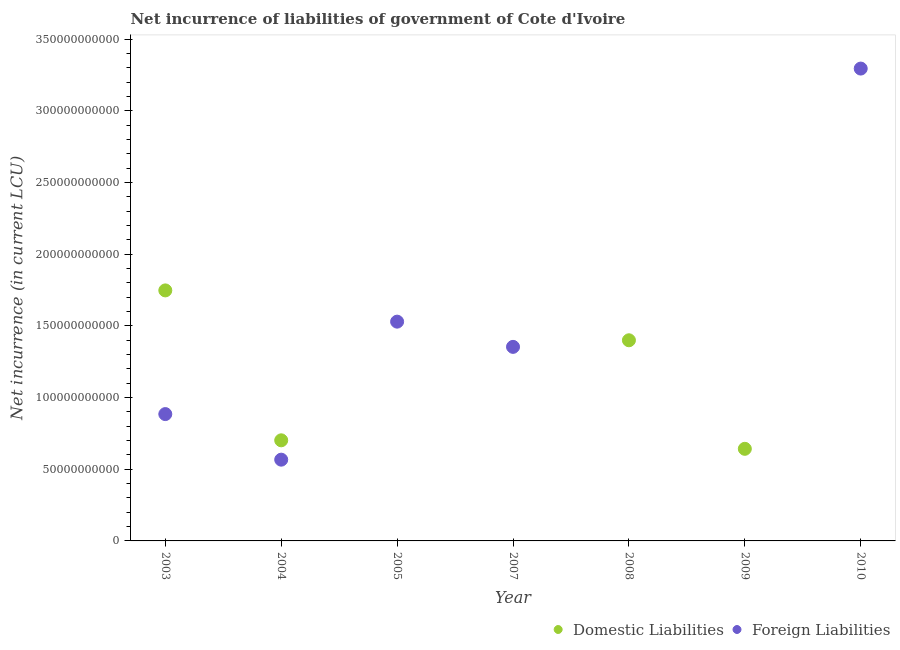What is the net incurrence of foreign liabilities in 2004?
Give a very brief answer. 5.67e+1. Across all years, what is the maximum net incurrence of foreign liabilities?
Ensure brevity in your answer.  3.30e+11. Across all years, what is the minimum net incurrence of foreign liabilities?
Provide a short and direct response. 0. In which year was the net incurrence of domestic liabilities maximum?
Ensure brevity in your answer.  2003. What is the total net incurrence of domestic liabilities in the graph?
Ensure brevity in your answer.  4.49e+11. What is the difference between the net incurrence of foreign liabilities in 2003 and that in 2007?
Offer a terse response. -4.69e+1. What is the difference between the net incurrence of foreign liabilities in 2004 and the net incurrence of domestic liabilities in 2005?
Your answer should be very brief. 5.67e+1. What is the average net incurrence of foreign liabilities per year?
Your answer should be very brief. 1.09e+11. In the year 2003, what is the difference between the net incurrence of foreign liabilities and net incurrence of domestic liabilities?
Offer a very short reply. -8.63e+1. In how many years, is the net incurrence of domestic liabilities greater than 90000000000 LCU?
Ensure brevity in your answer.  2. What is the ratio of the net incurrence of foreign liabilities in 2007 to that in 2010?
Ensure brevity in your answer.  0.41. Is the net incurrence of foreign liabilities in 2005 less than that in 2007?
Ensure brevity in your answer.  No. What is the difference between the highest and the second highest net incurrence of foreign liabilities?
Provide a short and direct response. 1.77e+11. What is the difference between the highest and the lowest net incurrence of foreign liabilities?
Ensure brevity in your answer.  3.30e+11. In how many years, is the net incurrence of domestic liabilities greater than the average net incurrence of domestic liabilities taken over all years?
Keep it short and to the point. 4. Is the net incurrence of domestic liabilities strictly less than the net incurrence of foreign liabilities over the years?
Your response must be concise. No. How many years are there in the graph?
Ensure brevity in your answer.  7. What is the difference between two consecutive major ticks on the Y-axis?
Offer a terse response. 5.00e+1. Are the values on the major ticks of Y-axis written in scientific E-notation?
Offer a terse response. No. Does the graph contain any zero values?
Your response must be concise. Yes. Does the graph contain grids?
Your response must be concise. No. How are the legend labels stacked?
Offer a very short reply. Horizontal. What is the title of the graph?
Offer a very short reply. Net incurrence of liabilities of government of Cote d'Ivoire. What is the label or title of the Y-axis?
Your response must be concise. Net incurrence (in current LCU). What is the Net incurrence (in current LCU) of Domestic Liabilities in 2003?
Provide a short and direct response. 1.75e+11. What is the Net incurrence (in current LCU) of Foreign Liabilities in 2003?
Your answer should be very brief. 8.85e+1. What is the Net incurrence (in current LCU) of Domestic Liabilities in 2004?
Offer a terse response. 7.02e+1. What is the Net incurrence (in current LCU) of Foreign Liabilities in 2004?
Offer a very short reply. 5.67e+1. What is the Net incurrence (in current LCU) in Foreign Liabilities in 2005?
Offer a terse response. 1.53e+11. What is the Net incurrence (in current LCU) in Domestic Liabilities in 2007?
Your response must be concise. 0. What is the Net incurrence (in current LCU) in Foreign Liabilities in 2007?
Ensure brevity in your answer.  1.35e+11. What is the Net incurrence (in current LCU) of Domestic Liabilities in 2008?
Give a very brief answer. 1.40e+11. What is the Net incurrence (in current LCU) of Foreign Liabilities in 2008?
Make the answer very short. 0. What is the Net incurrence (in current LCU) in Domestic Liabilities in 2009?
Provide a short and direct response. 6.43e+1. What is the Net incurrence (in current LCU) of Foreign Liabilities in 2010?
Make the answer very short. 3.30e+11. Across all years, what is the maximum Net incurrence (in current LCU) of Domestic Liabilities?
Your answer should be compact. 1.75e+11. Across all years, what is the maximum Net incurrence (in current LCU) in Foreign Liabilities?
Your response must be concise. 3.30e+11. Across all years, what is the minimum Net incurrence (in current LCU) in Domestic Liabilities?
Provide a short and direct response. 0. What is the total Net incurrence (in current LCU) of Domestic Liabilities in the graph?
Offer a very short reply. 4.49e+11. What is the total Net incurrence (in current LCU) of Foreign Liabilities in the graph?
Provide a short and direct response. 7.63e+11. What is the difference between the Net incurrence (in current LCU) in Domestic Liabilities in 2003 and that in 2004?
Your answer should be compact. 1.05e+11. What is the difference between the Net incurrence (in current LCU) of Foreign Liabilities in 2003 and that in 2004?
Your answer should be very brief. 3.18e+1. What is the difference between the Net incurrence (in current LCU) in Foreign Liabilities in 2003 and that in 2005?
Offer a terse response. -6.45e+1. What is the difference between the Net incurrence (in current LCU) of Foreign Liabilities in 2003 and that in 2007?
Your response must be concise. -4.69e+1. What is the difference between the Net incurrence (in current LCU) in Domestic Liabilities in 2003 and that in 2008?
Your answer should be very brief. 3.48e+1. What is the difference between the Net incurrence (in current LCU) of Domestic Liabilities in 2003 and that in 2009?
Ensure brevity in your answer.  1.11e+11. What is the difference between the Net incurrence (in current LCU) in Foreign Liabilities in 2003 and that in 2010?
Your response must be concise. -2.41e+11. What is the difference between the Net incurrence (in current LCU) of Foreign Liabilities in 2004 and that in 2005?
Offer a very short reply. -9.63e+1. What is the difference between the Net incurrence (in current LCU) in Foreign Liabilities in 2004 and that in 2007?
Your answer should be very brief. -7.87e+1. What is the difference between the Net incurrence (in current LCU) of Domestic Liabilities in 2004 and that in 2008?
Give a very brief answer. -6.98e+1. What is the difference between the Net incurrence (in current LCU) in Domestic Liabilities in 2004 and that in 2009?
Provide a succinct answer. 5.93e+09. What is the difference between the Net incurrence (in current LCU) in Foreign Liabilities in 2004 and that in 2010?
Your answer should be very brief. -2.73e+11. What is the difference between the Net incurrence (in current LCU) of Foreign Liabilities in 2005 and that in 2007?
Give a very brief answer. 1.76e+1. What is the difference between the Net incurrence (in current LCU) of Foreign Liabilities in 2005 and that in 2010?
Offer a terse response. -1.77e+11. What is the difference between the Net incurrence (in current LCU) in Foreign Liabilities in 2007 and that in 2010?
Offer a terse response. -1.94e+11. What is the difference between the Net incurrence (in current LCU) in Domestic Liabilities in 2008 and that in 2009?
Provide a short and direct response. 7.57e+1. What is the difference between the Net incurrence (in current LCU) in Domestic Liabilities in 2003 and the Net incurrence (in current LCU) in Foreign Liabilities in 2004?
Ensure brevity in your answer.  1.18e+11. What is the difference between the Net incurrence (in current LCU) in Domestic Liabilities in 2003 and the Net incurrence (in current LCU) in Foreign Liabilities in 2005?
Give a very brief answer. 2.18e+1. What is the difference between the Net incurrence (in current LCU) of Domestic Liabilities in 2003 and the Net incurrence (in current LCU) of Foreign Liabilities in 2007?
Your response must be concise. 3.94e+1. What is the difference between the Net incurrence (in current LCU) of Domestic Liabilities in 2003 and the Net incurrence (in current LCU) of Foreign Liabilities in 2010?
Give a very brief answer. -1.55e+11. What is the difference between the Net incurrence (in current LCU) of Domestic Liabilities in 2004 and the Net incurrence (in current LCU) of Foreign Liabilities in 2005?
Provide a succinct answer. -8.28e+1. What is the difference between the Net incurrence (in current LCU) of Domestic Liabilities in 2004 and the Net incurrence (in current LCU) of Foreign Liabilities in 2007?
Ensure brevity in your answer.  -6.52e+1. What is the difference between the Net incurrence (in current LCU) of Domestic Liabilities in 2004 and the Net incurrence (in current LCU) of Foreign Liabilities in 2010?
Your answer should be compact. -2.59e+11. What is the difference between the Net incurrence (in current LCU) of Domestic Liabilities in 2008 and the Net incurrence (in current LCU) of Foreign Liabilities in 2010?
Ensure brevity in your answer.  -1.90e+11. What is the difference between the Net incurrence (in current LCU) of Domestic Liabilities in 2009 and the Net incurrence (in current LCU) of Foreign Liabilities in 2010?
Ensure brevity in your answer.  -2.65e+11. What is the average Net incurrence (in current LCU) in Domestic Liabilities per year?
Provide a short and direct response. 6.42e+1. What is the average Net incurrence (in current LCU) of Foreign Liabilities per year?
Give a very brief answer. 1.09e+11. In the year 2003, what is the difference between the Net incurrence (in current LCU) in Domestic Liabilities and Net incurrence (in current LCU) in Foreign Liabilities?
Make the answer very short. 8.63e+1. In the year 2004, what is the difference between the Net incurrence (in current LCU) of Domestic Liabilities and Net incurrence (in current LCU) of Foreign Liabilities?
Provide a short and direct response. 1.35e+1. What is the ratio of the Net incurrence (in current LCU) in Domestic Liabilities in 2003 to that in 2004?
Make the answer very short. 2.49. What is the ratio of the Net incurrence (in current LCU) of Foreign Liabilities in 2003 to that in 2004?
Provide a short and direct response. 1.56. What is the ratio of the Net incurrence (in current LCU) in Foreign Liabilities in 2003 to that in 2005?
Your answer should be very brief. 0.58. What is the ratio of the Net incurrence (in current LCU) of Foreign Liabilities in 2003 to that in 2007?
Make the answer very short. 0.65. What is the ratio of the Net incurrence (in current LCU) in Domestic Liabilities in 2003 to that in 2008?
Keep it short and to the point. 1.25. What is the ratio of the Net incurrence (in current LCU) in Domestic Liabilities in 2003 to that in 2009?
Give a very brief answer. 2.72. What is the ratio of the Net incurrence (in current LCU) in Foreign Liabilities in 2003 to that in 2010?
Offer a very short reply. 0.27. What is the ratio of the Net incurrence (in current LCU) of Foreign Liabilities in 2004 to that in 2005?
Provide a short and direct response. 0.37. What is the ratio of the Net incurrence (in current LCU) of Foreign Liabilities in 2004 to that in 2007?
Your response must be concise. 0.42. What is the ratio of the Net incurrence (in current LCU) of Domestic Liabilities in 2004 to that in 2008?
Offer a very short reply. 0.5. What is the ratio of the Net incurrence (in current LCU) of Domestic Liabilities in 2004 to that in 2009?
Provide a succinct answer. 1.09. What is the ratio of the Net incurrence (in current LCU) of Foreign Liabilities in 2004 to that in 2010?
Your response must be concise. 0.17. What is the ratio of the Net incurrence (in current LCU) of Foreign Liabilities in 2005 to that in 2007?
Ensure brevity in your answer.  1.13. What is the ratio of the Net incurrence (in current LCU) in Foreign Liabilities in 2005 to that in 2010?
Give a very brief answer. 0.46. What is the ratio of the Net incurrence (in current LCU) of Foreign Liabilities in 2007 to that in 2010?
Your answer should be compact. 0.41. What is the ratio of the Net incurrence (in current LCU) of Domestic Liabilities in 2008 to that in 2009?
Offer a terse response. 2.18. What is the difference between the highest and the second highest Net incurrence (in current LCU) of Domestic Liabilities?
Give a very brief answer. 3.48e+1. What is the difference between the highest and the second highest Net incurrence (in current LCU) in Foreign Liabilities?
Keep it short and to the point. 1.77e+11. What is the difference between the highest and the lowest Net incurrence (in current LCU) in Domestic Liabilities?
Offer a very short reply. 1.75e+11. What is the difference between the highest and the lowest Net incurrence (in current LCU) in Foreign Liabilities?
Keep it short and to the point. 3.30e+11. 